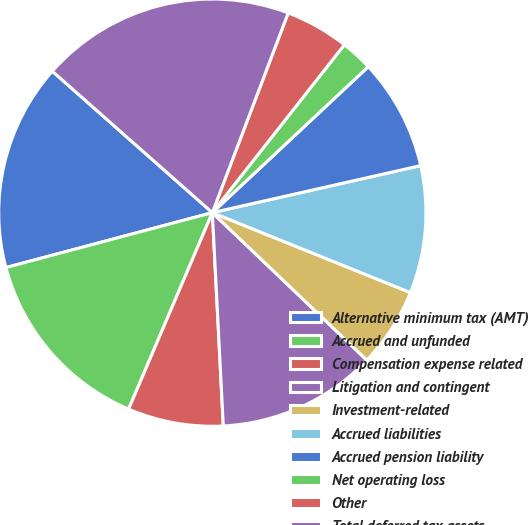Convert chart to OTSL. <chart><loc_0><loc_0><loc_500><loc_500><pie_chart><fcel>Alternative minimum tax (AMT)<fcel>Accrued and unfunded<fcel>Compensation expense related<fcel>Litigation and contingent<fcel>Investment-related<fcel>Accrued liabilities<fcel>Accrued pension liability<fcel>Net operating loss<fcel>Other<fcel>Total deferred tax assets<nl><fcel>15.66%<fcel>14.45%<fcel>7.23%<fcel>12.05%<fcel>6.03%<fcel>9.64%<fcel>8.44%<fcel>2.42%<fcel>4.83%<fcel>19.26%<nl></chart> 